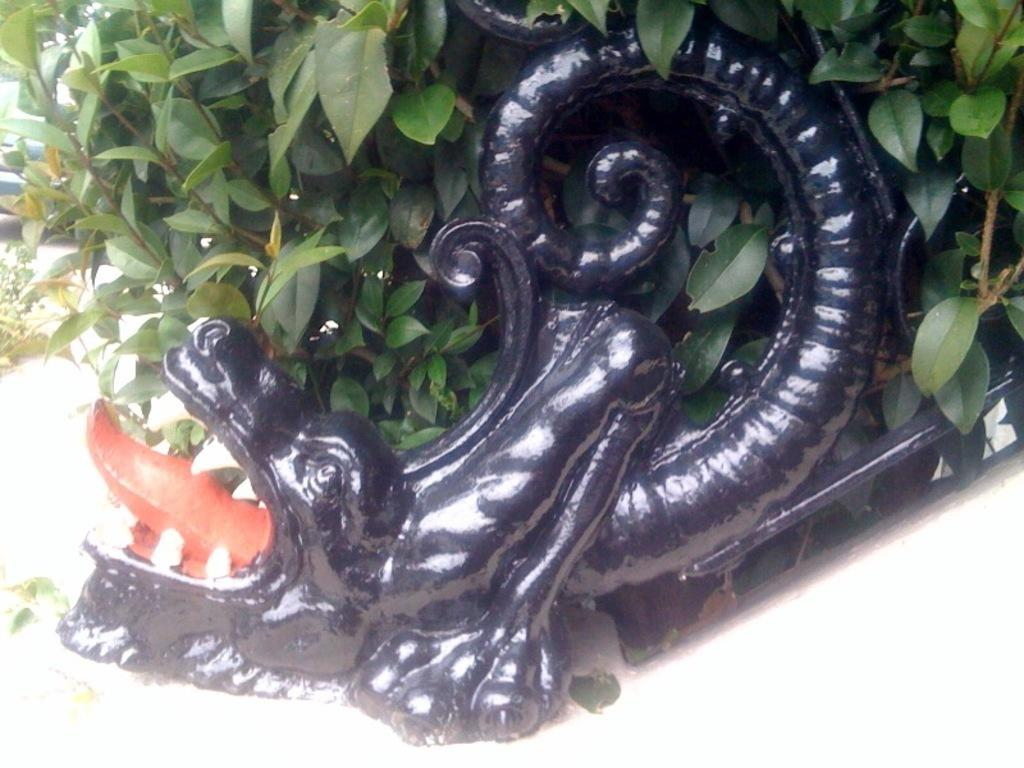What is in the pot that is visible in the image? There is a pot with plants in the image. What decorative element is on the pot? There is a sculpture on the pot. What can be seen on the left side of the image? There is a vehicle on the left side of the image. What is in front of the vehicle in the image? There are plants before the vehicle. What type of cable is being used to connect the plants to the vehicle in the image? There is no cable connecting the plants to the vehicle in the image. 